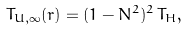Convert formula to latex. <formula><loc_0><loc_0><loc_500><loc_500>T _ { U , \infty } ( r ) = ( 1 - N ^ { 2 } ) ^ { 2 } \, T _ { H } ,</formula> 